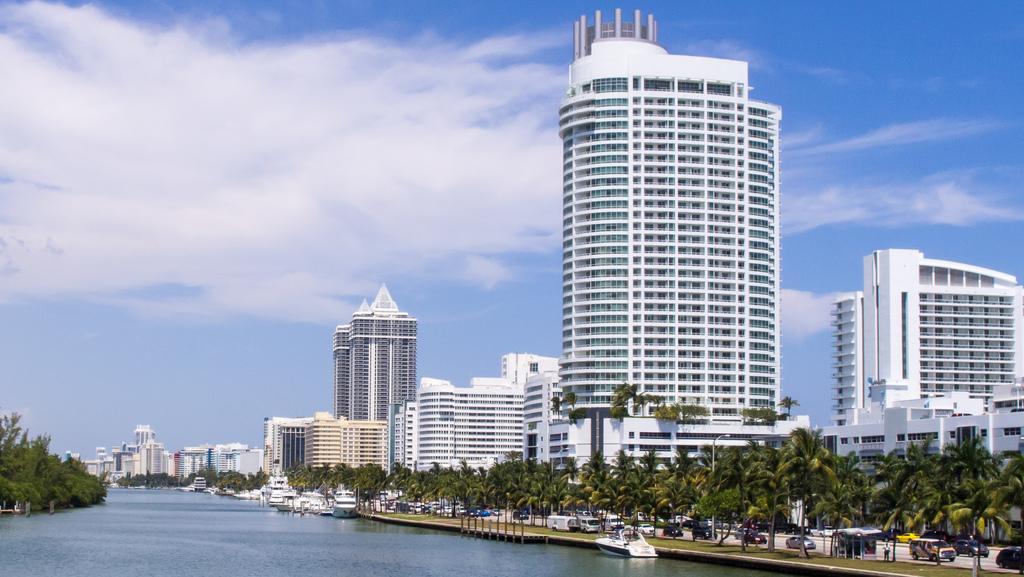Can you describe this image briefly? In this image in the center there are some buildings and trees and there is a walkway, on the walkway and there are some vehicles and at the bottom there is a river. And in the river we could see some boats, and also there are trees. At the top there is sky. 